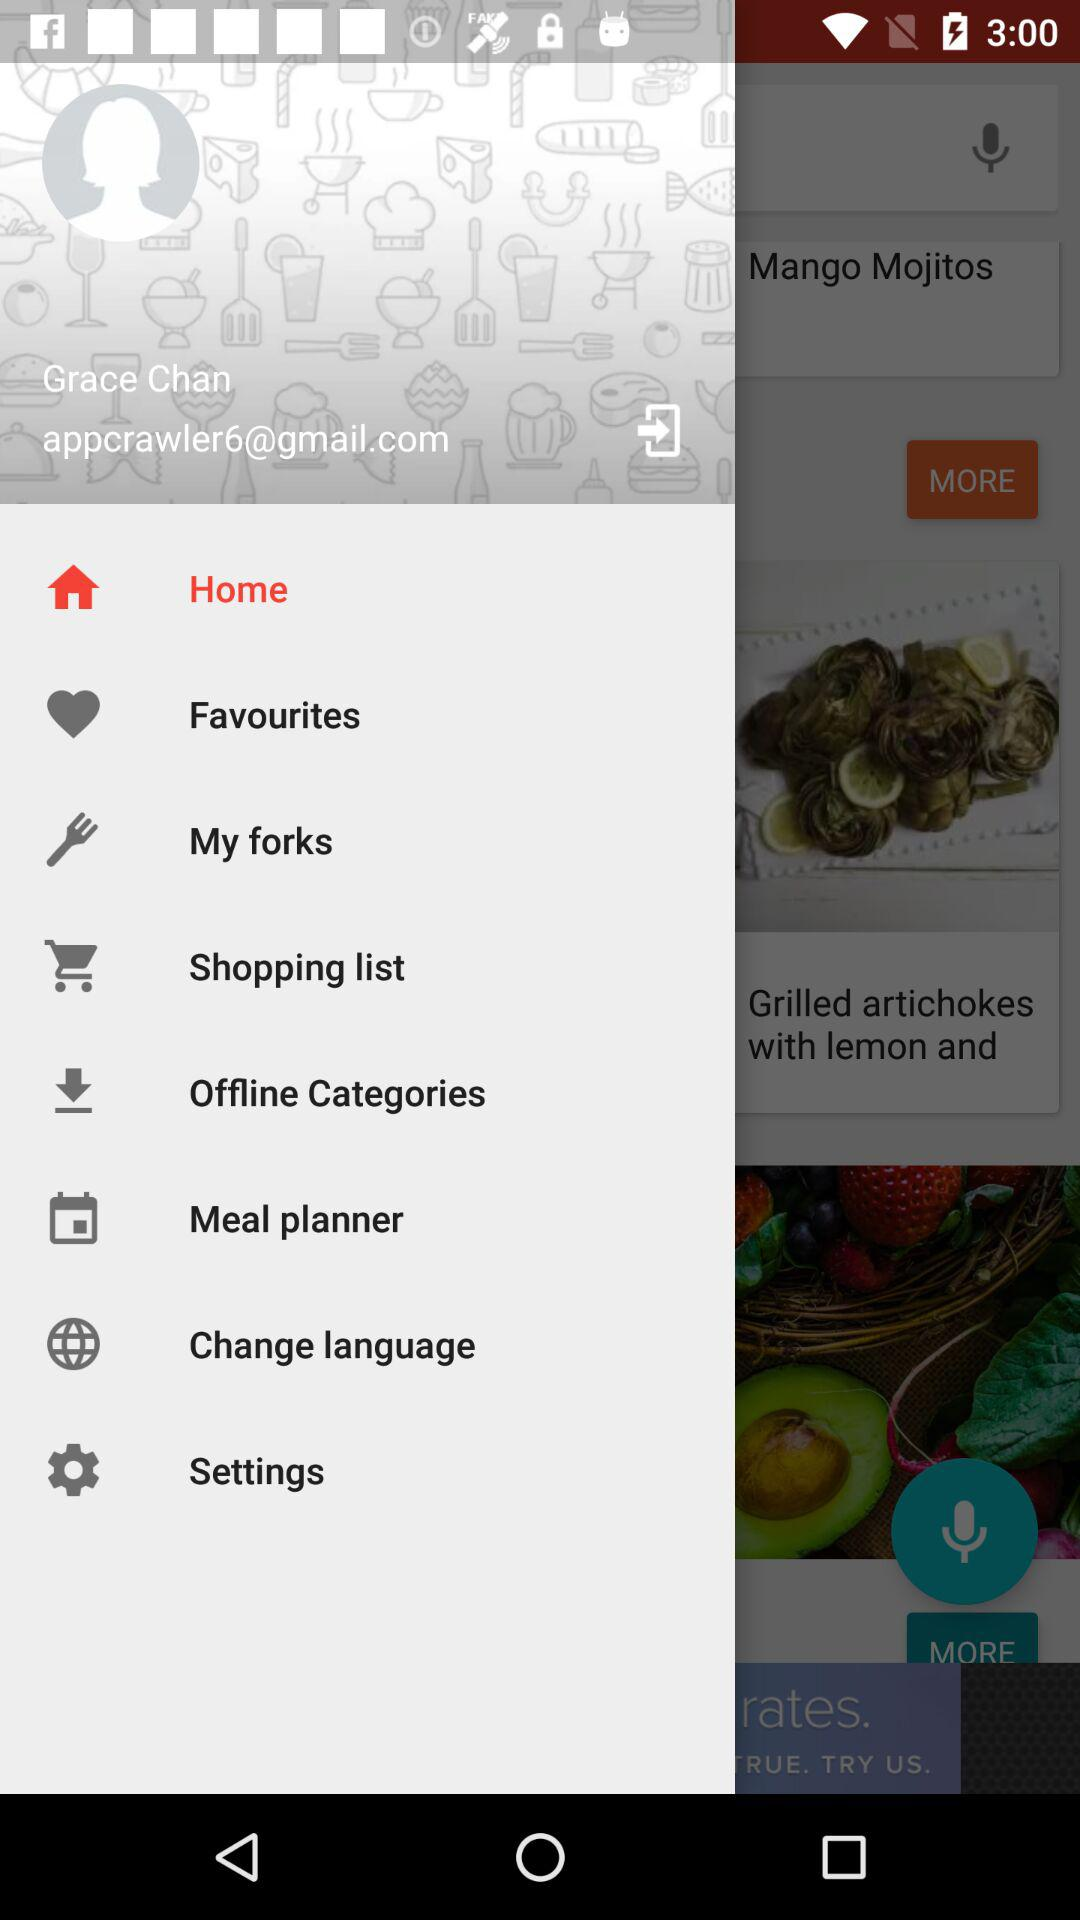What is the email address? The email address is appcrawler6@gmail.com. 